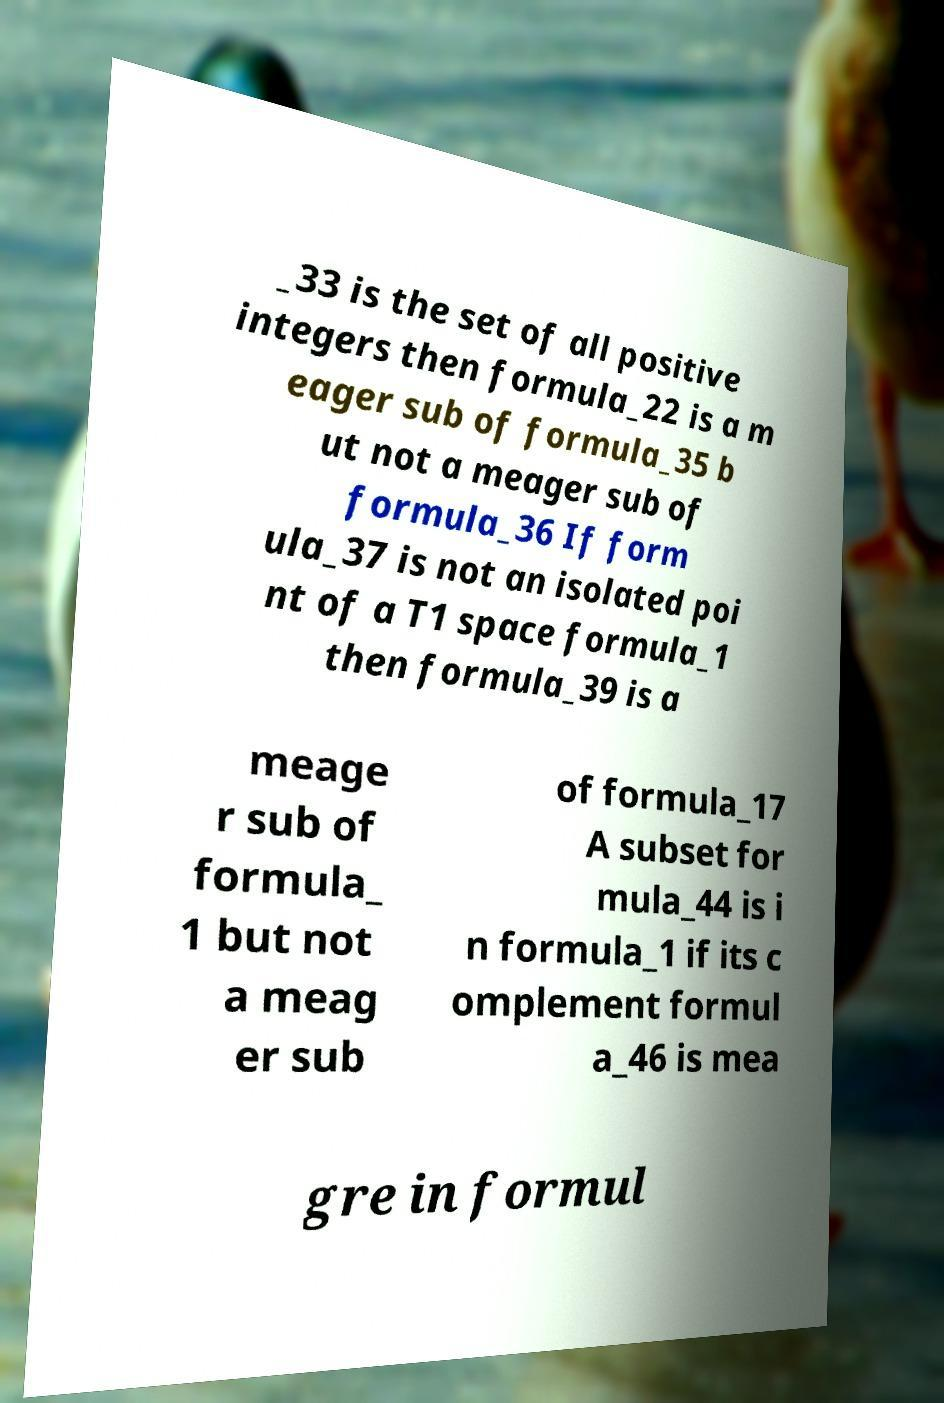Please read and relay the text visible in this image. What does it say? _33 is the set of all positive integers then formula_22 is a m eager sub of formula_35 b ut not a meager sub of formula_36 If form ula_37 is not an isolated poi nt of a T1 space formula_1 then formula_39 is a meage r sub of formula_ 1 but not a meag er sub of formula_17 A subset for mula_44 is i n formula_1 if its c omplement formul a_46 is mea gre in formul 